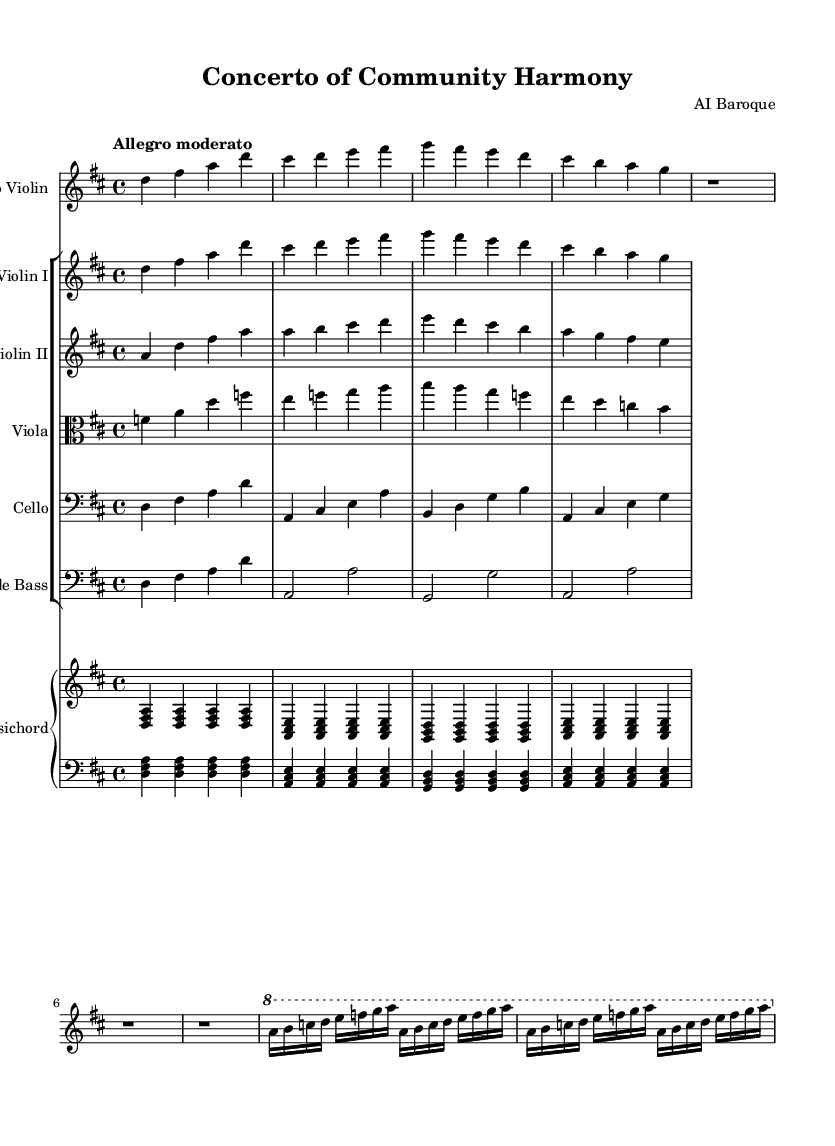What is the key signature of this music? The key signature appears at the beginning of the first staff and shows two sharps. This indicates that the key of the piece is D major.
Answer: D major What is the time signature of this music? The time signature is found at the beginning of the score. It is written as a fraction that indicates four beats in each measure, specifically 4 over 4.
Answer: 4/4 What tempo marking is indicated in the music? The tempo is indicated at the beginning of the score. It reads "Allegro moderato," which describes the speed of the piece as moderately fast.
Answer: Allegro moderato How many measures are in the solo violin part? By counting the individual measures in the solo violin part written in the music, I notice there are a total of 7 measures in that section.
Answer: 7 What instruments are included in the ensemble? I look at the names of the staves in the score and see that they include Solo Violin, Violin I, Violin II, Viola, Cello, Double Bass, and Harpsichord.
Answer: Solo Violin, Violin I, Violin II, Viola, Cello, Double Bass, Harpsichord What is the structural form of the piece? The piece exhibits a call-and-response style, which is characteristic of Baroque concertos, allowing for both individual expressions from the soloists and collective input from the ensemble.
Answer: Concerto form 